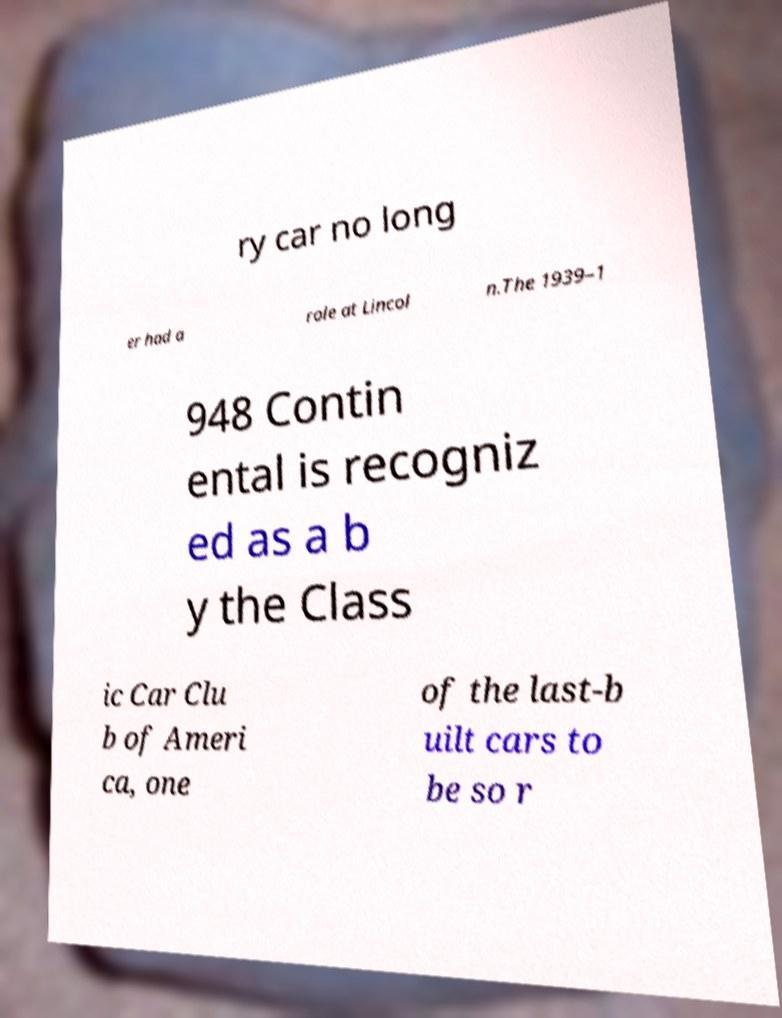I need the written content from this picture converted into text. Can you do that? ry car no long er had a role at Lincol n.The 1939–1 948 Contin ental is recogniz ed as a b y the Class ic Car Clu b of Ameri ca, one of the last-b uilt cars to be so r 